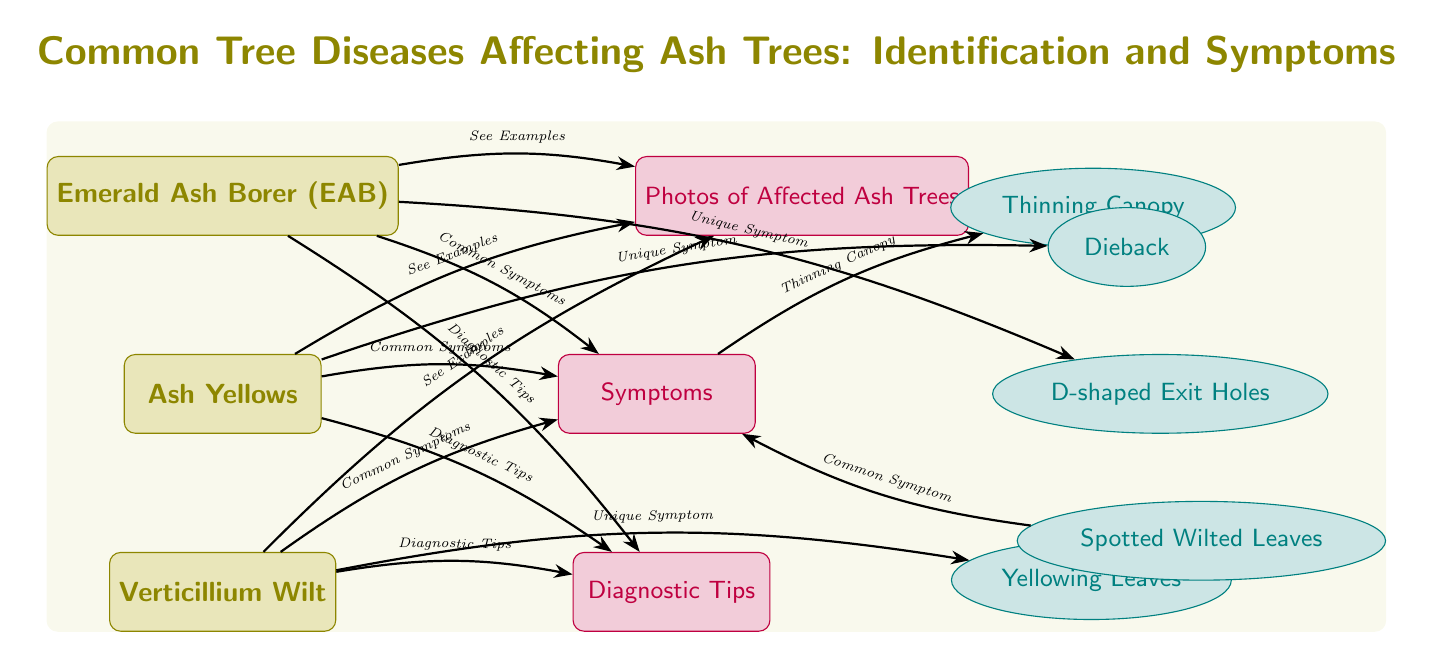What are the three diseases listed for ash trees? The diagram shows three diseases affecting ash trees: Emerald Ash Borer (EAB), Ash Yellows, and Verticillium Wilt, listed in a vertical arrangement.
Answer: Emerald Ash Borer (EAB), Ash Yellows, Verticillium Wilt How many common symptoms are connected to the symptoms node? The symptoms node connects to four common symptoms: Thinning Canopy, D-shaped Exit Holes, Yellowing Leaves, and Dieback. Thus, there are four symptoms represented in total.
Answer: 4 What unique symptom is associated with the Emerald Ash Borer? The diagram indicates that the unique symptom associated with the Emerald Ash Borer is "D-shaped Exit Holes," which is specifically connected to the EAB disease node.
Answer: D-shaped Exit Holes Which disease is linked with Yellowing Leaves as a unique symptom? The only disease linked with Yellowing Leaves as a unique symptom is Verticillium Wilt, as shown by the direct arrow connection from the disease node to the unique symptom.
Answer: Verticillium Wilt What type of information can be found associated with each disease? The diagram connects a "Photos of Affected Ash Trees," "Symptoms," and "Diagnostic Tips" to each disease, providing a complete set of relevant information for all three diseases listed.
Answer: Photos of Affected Ash Trees, Symptoms, Diagnostic Tips Which symptom that is common can be related with the diagnostic tips node? The common symptom "Spotted Wilted Leaves" is related back to the symptoms node, which subsequently connects to the diagnostic tips node, demonstrating its relevance in interpretation and diagnosis.
Answer: Spotted Wilted Leaves 